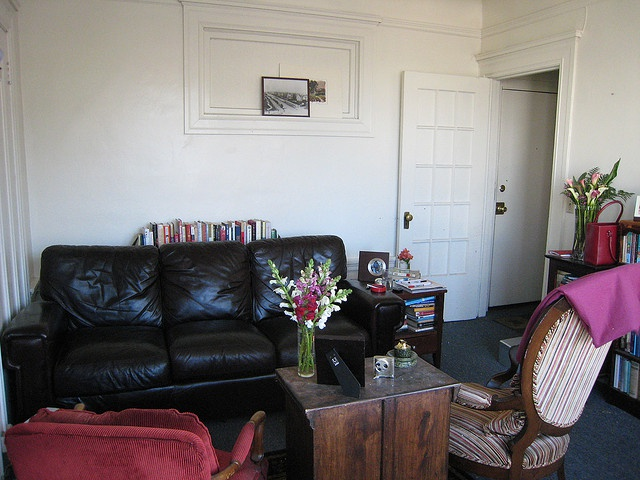Describe the objects in this image and their specific colors. I can see couch in gray, black, navy, and blue tones, chair in gray, black, lightgray, and darkgray tones, chair in gray, maroon, black, and brown tones, book in gray, lightgray, darkgray, and lightblue tones, and handbag in gray, maroon, darkgray, black, and brown tones in this image. 